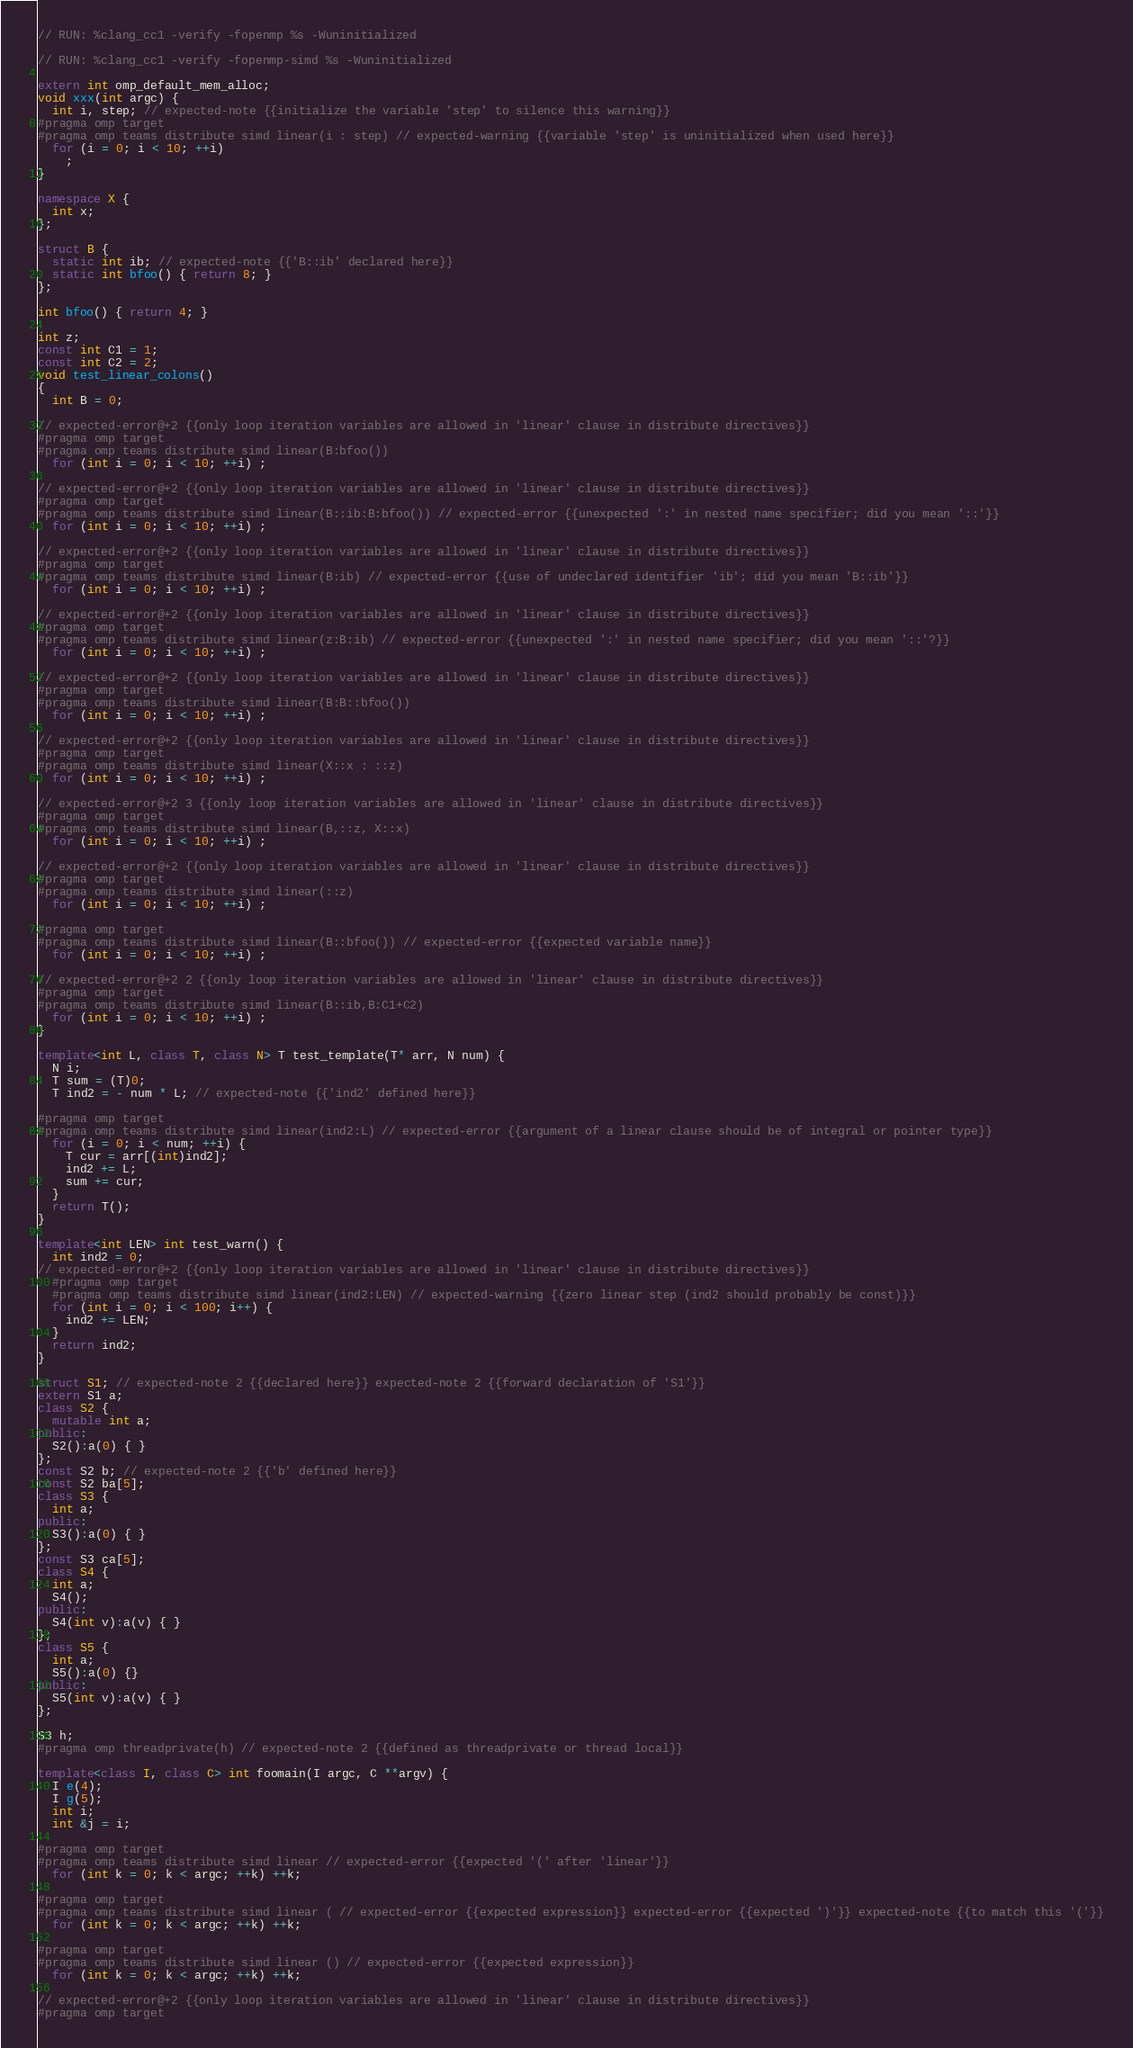<code> <loc_0><loc_0><loc_500><loc_500><_C++_>// RUN: %clang_cc1 -verify -fopenmp %s -Wuninitialized

// RUN: %clang_cc1 -verify -fopenmp-simd %s -Wuninitialized

extern int omp_default_mem_alloc;
void xxx(int argc) {
  int i, step; // expected-note {{initialize the variable 'step' to silence this warning}}
#pragma omp target
#pragma omp teams distribute simd linear(i : step) // expected-warning {{variable 'step' is uninitialized when used here}}
  for (i = 0; i < 10; ++i)
    ;
}

namespace X {
  int x;
};

struct B {
  static int ib; // expected-note {{'B::ib' declared here}}
  static int bfoo() { return 8; }
};

int bfoo() { return 4; }

int z;
const int C1 = 1;
const int C2 = 2;
void test_linear_colons()
{
  int B = 0;

// expected-error@+2 {{only loop iteration variables are allowed in 'linear' clause in distribute directives}}
#pragma omp target
#pragma omp teams distribute simd linear(B:bfoo())
  for (int i = 0; i < 10; ++i) ;

// expected-error@+2 {{only loop iteration variables are allowed in 'linear' clause in distribute directives}}
#pragma omp target
#pragma omp teams distribute simd linear(B::ib:B:bfoo()) // expected-error {{unexpected ':' in nested name specifier; did you mean '::'}}
  for (int i = 0; i < 10; ++i) ;

// expected-error@+2 {{only loop iteration variables are allowed in 'linear' clause in distribute directives}}
#pragma omp target
#pragma omp teams distribute simd linear(B:ib) // expected-error {{use of undeclared identifier 'ib'; did you mean 'B::ib'}}
  for (int i = 0; i < 10; ++i) ;

// expected-error@+2 {{only loop iteration variables are allowed in 'linear' clause in distribute directives}}
#pragma omp target
#pragma omp teams distribute simd linear(z:B:ib) // expected-error {{unexpected ':' in nested name specifier; did you mean '::'?}}
  for (int i = 0; i < 10; ++i) ;

// expected-error@+2 {{only loop iteration variables are allowed in 'linear' clause in distribute directives}}
#pragma omp target
#pragma omp teams distribute simd linear(B:B::bfoo())
  for (int i = 0; i < 10; ++i) ;

// expected-error@+2 {{only loop iteration variables are allowed in 'linear' clause in distribute directives}}
#pragma omp target
#pragma omp teams distribute simd linear(X::x : ::z)
  for (int i = 0; i < 10; ++i) ;

// expected-error@+2 3 {{only loop iteration variables are allowed in 'linear' clause in distribute directives}}
#pragma omp target
#pragma omp teams distribute simd linear(B,::z, X::x)
  for (int i = 0; i < 10; ++i) ;

// expected-error@+2 {{only loop iteration variables are allowed in 'linear' clause in distribute directives}}
#pragma omp target
#pragma omp teams distribute simd linear(::z)
  for (int i = 0; i < 10; ++i) ;

#pragma omp target
#pragma omp teams distribute simd linear(B::bfoo()) // expected-error {{expected variable name}}
  for (int i = 0; i < 10; ++i) ;

// expected-error@+2 2 {{only loop iteration variables are allowed in 'linear' clause in distribute directives}}
#pragma omp target
#pragma omp teams distribute simd linear(B::ib,B:C1+C2)
  for (int i = 0; i < 10; ++i) ;
}

template<int L, class T, class N> T test_template(T* arr, N num) {
  N i;
  T sum = (T)0;
  T ind2 = - num * L; // expected-note {{'ind2' defined here}}

#pragma omp target
#pragma omp teams distribute simd linear(ind2:L) // expected-error {{argument of a linear clause should be of integral or pointer type}}
  for (i = 0; i < num; ++i) {
    T cur = arr[(int)ind2];
    ind2 += L;
    sum += cur;
  }
  return T();
}

template<int LEN> int test_warn() {
  int ind2 = 0;
// expected-error@+2 {{only loop iteration variables are allowed in 'linear' clause in distribute directives}}
  #pragma omp target
  #pragma omp teams distribute simd linear(ind2:LEN) // expected-warning {{zero linear step (ind2 should probably be const)}}
  for (int i = 0; i < 100; i++) {
    ind2 += LEN;
  }
  return ind2;
}

struct S1; // expected-note 2 {{declared here}} expected-note 2 {{forward declaration of 'S1'}}
extern S1 a;
class S2 {
  mutable int a;
public:
  S2():a(0) { }
};
const S2 b; // expected-note 2 {{'b' defined here}}
const S2 ba[5];
class S3 {
  int a;
public:
  S3():a(0) { }
};
const S3 ca[5];
class S4 {
  int a;
  S4();
public:
  S4(int v):a(v) { }
};
class S5 {
  int a;
  S5():a(0) {}
public:
  S5(int v):a(v) { }
};

S3 h;
#pragma omp threadprivate(h) // expected-note 2 {{defined as threadprivate or thread local}}

template<class I, class C> int foomain(I argc, C **argv) {
  I e(4);
  I g(5);
  int i;
  int &j = i;

#pragma omp target
#pragma omp teams distribute simd linear // expected-error {{expected '(' after 'linear'}}
  for (int k = 0; k < argc; ++k) ++k;

#pragma omp target
#pragma omp teams distribute simd linear ( // expected-error {{expected expression}} expected-error {{expected ')'}} expected-note {{to match this '('}}
  for (int k = 0; k < argc; ++k) ++k;

#pragma omp target
#pragma omp teams distribute simd linear () // expected-error {{expected expression}}
  for (int k = 0; k < argc; ++k) ++k;

// expected-error@+2 {{only loop iteration variables are allowed in 'linear' clause in distribute directives}}
#pragma omp target</code> 